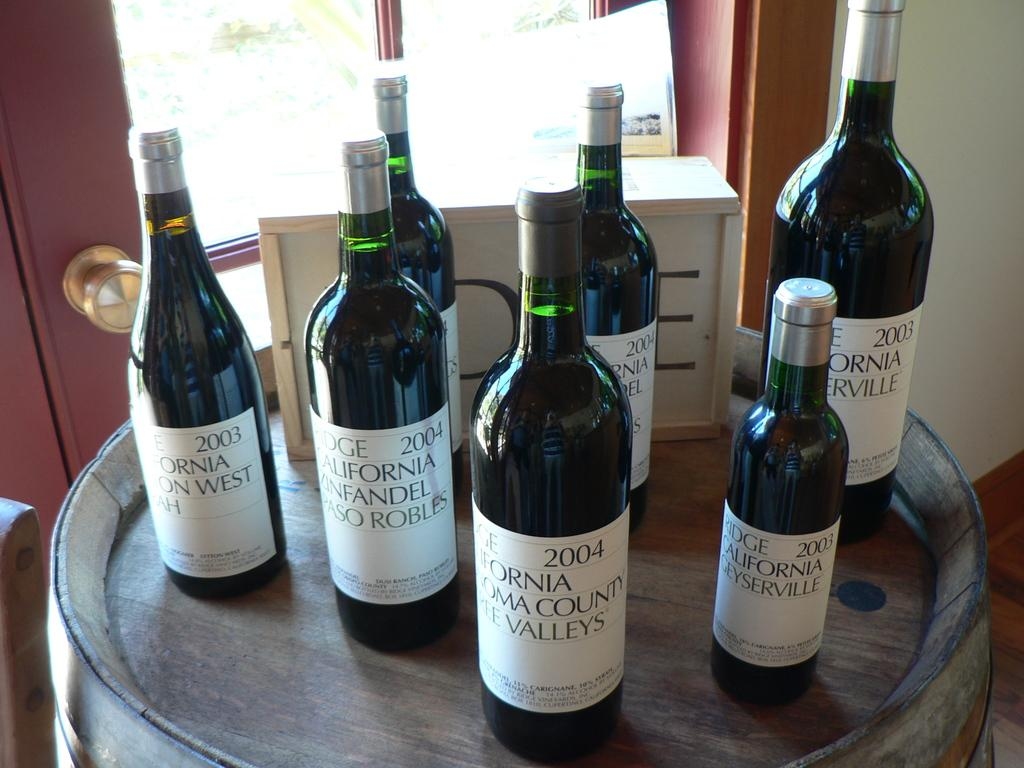Provide a one-sentence caption for the provided image. several wine bottles from a california company from the early 2000s. 